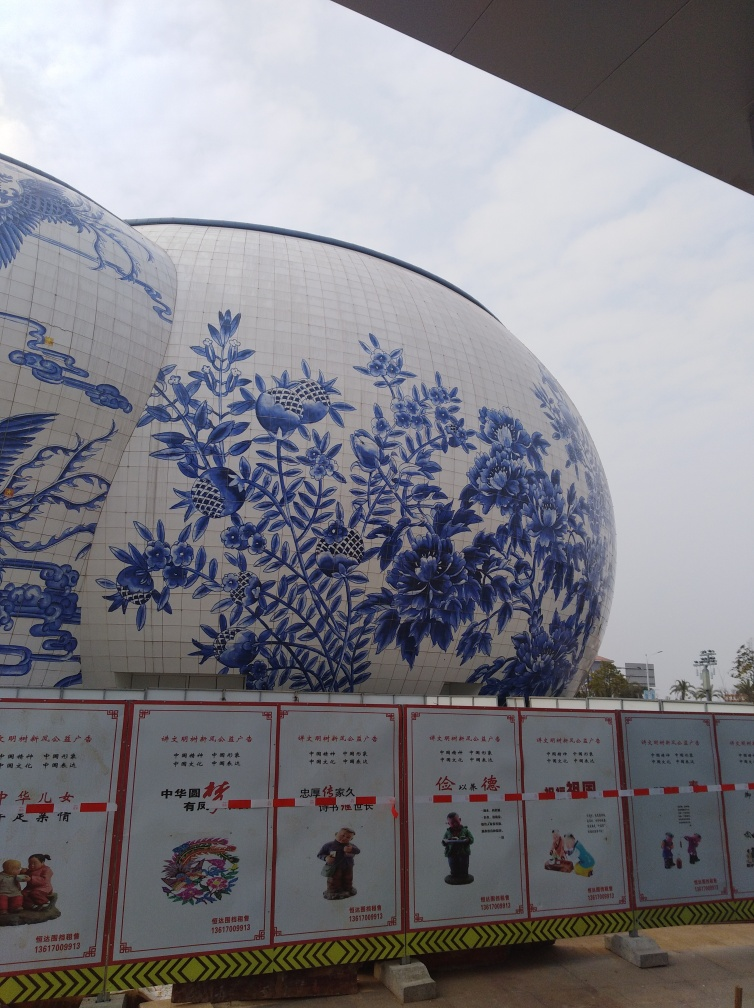What can you infer about the location or the setting from the image? The structure's design carries a strong Chinese influence, implying that it could be located in China or a place with a significant Chinese cultural presence. The weather appears to be overcast, typical of many regions in China. The text on the signage is in Chinese, supporting the likelihood that this is in China. Additionally, the presence of protective barriers suggests that the area may be under construction or undergoing renovations. 